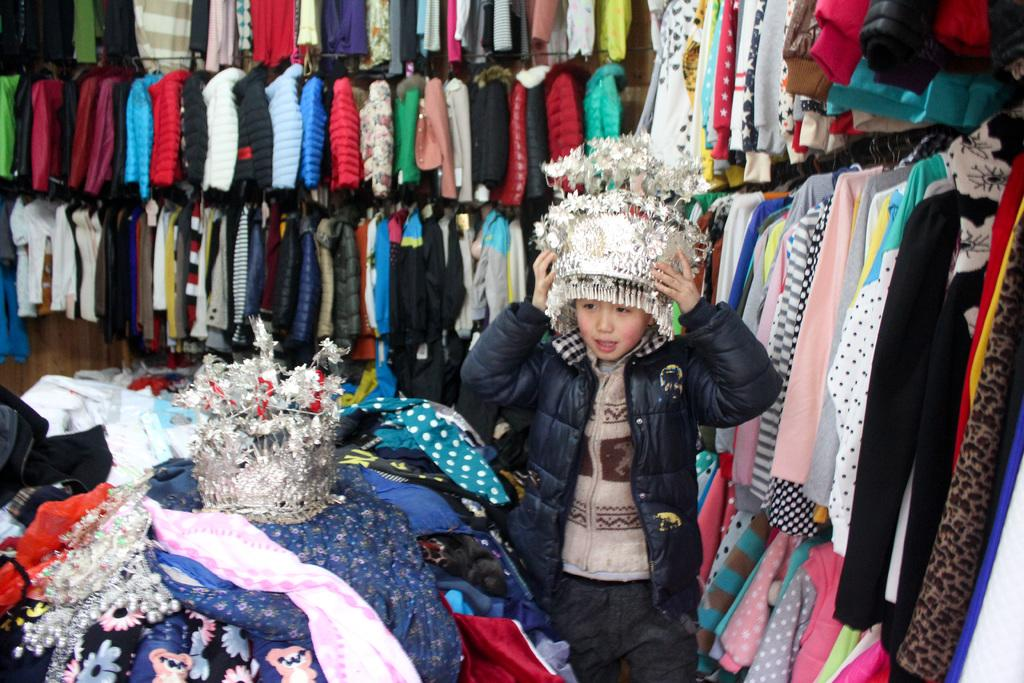What is the main subject of the image? The main subject of the image is a kid. What is the kid wearing in the image? The kid is wearing a black jacket and headwear. What else can be seen in the image besides the kid? There are several clothes and jackets hanged on hangers in the background. Can you tell me how many sticks are visible in the image? There are no sticks visible in the image. What type of eggnog is being served in the image? There is no eggnog present in the image. 